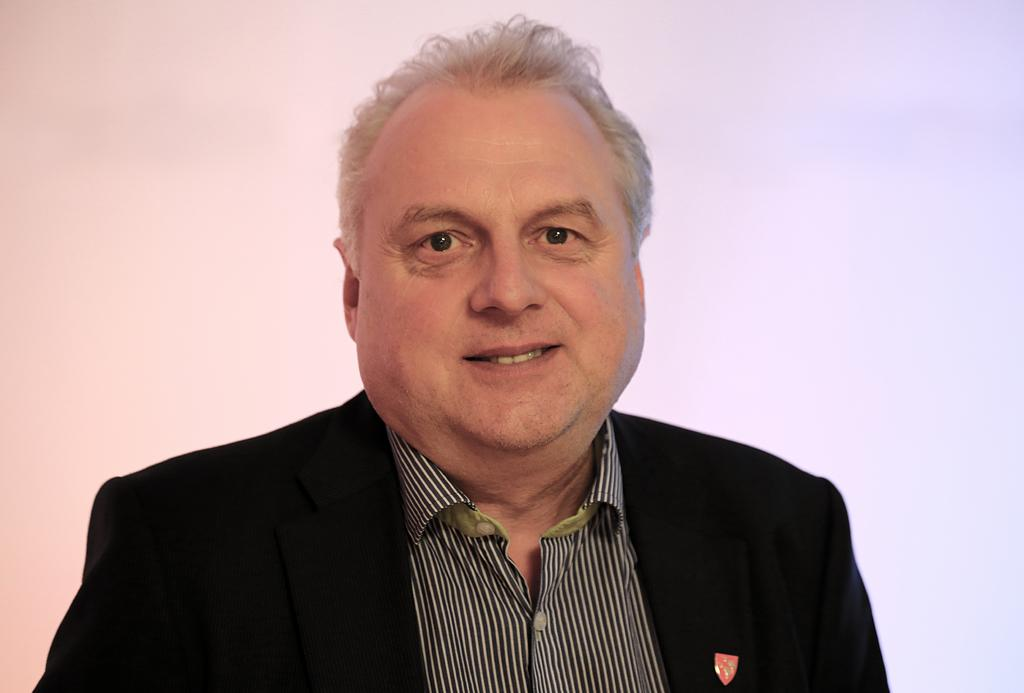Who or what is the main subject in the image? There is a person in the image. What is the person wearing on their upper body? The person is wearing a black and white shirt and a black colored blazer. What colors can be seen in the background of the image? The background of the image is blue and pink colored. What type of beef dish is being prepared by the baby in the image? There is no baby or beef dish present in the image. 